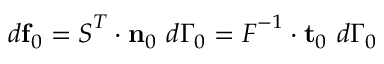Convert formula to latex. <formula><loc_0><loc_0><loc_500><loc_500>d f _ { 0 } = { S } ^ { T } \cdot n _ { 0 } d \Gamma _ { 0 } = { F } ^ { - 1 } \cdot t _ { 0 } d \Gamma _ { 0 }</formula> 